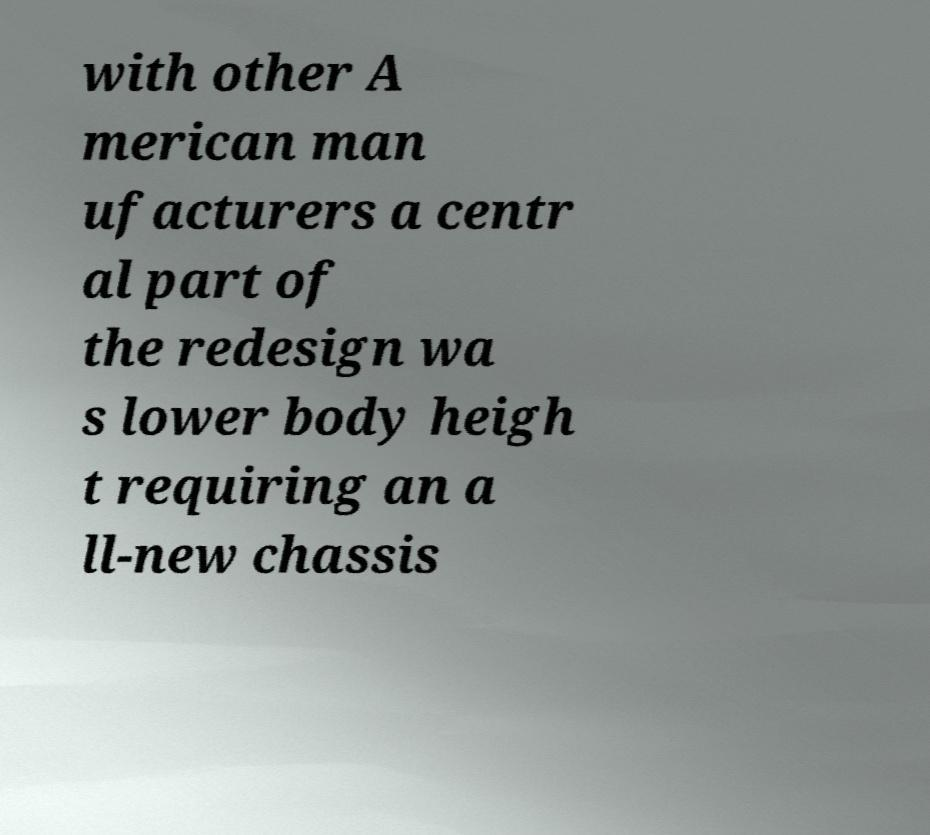What messages or text are displayed in this image? I need them in a readable, typed format. with other A merican man ufacturers a centr al part of the redesign wa s lower body heigh t requiring an a ll-new chassis 